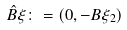Convert formula to latex. <formula><loc_0><loc_0><loc_500><loc_500>\hat { B } \xi \colon = ( 0 , - B \xi _ { 2 } )</formula> 